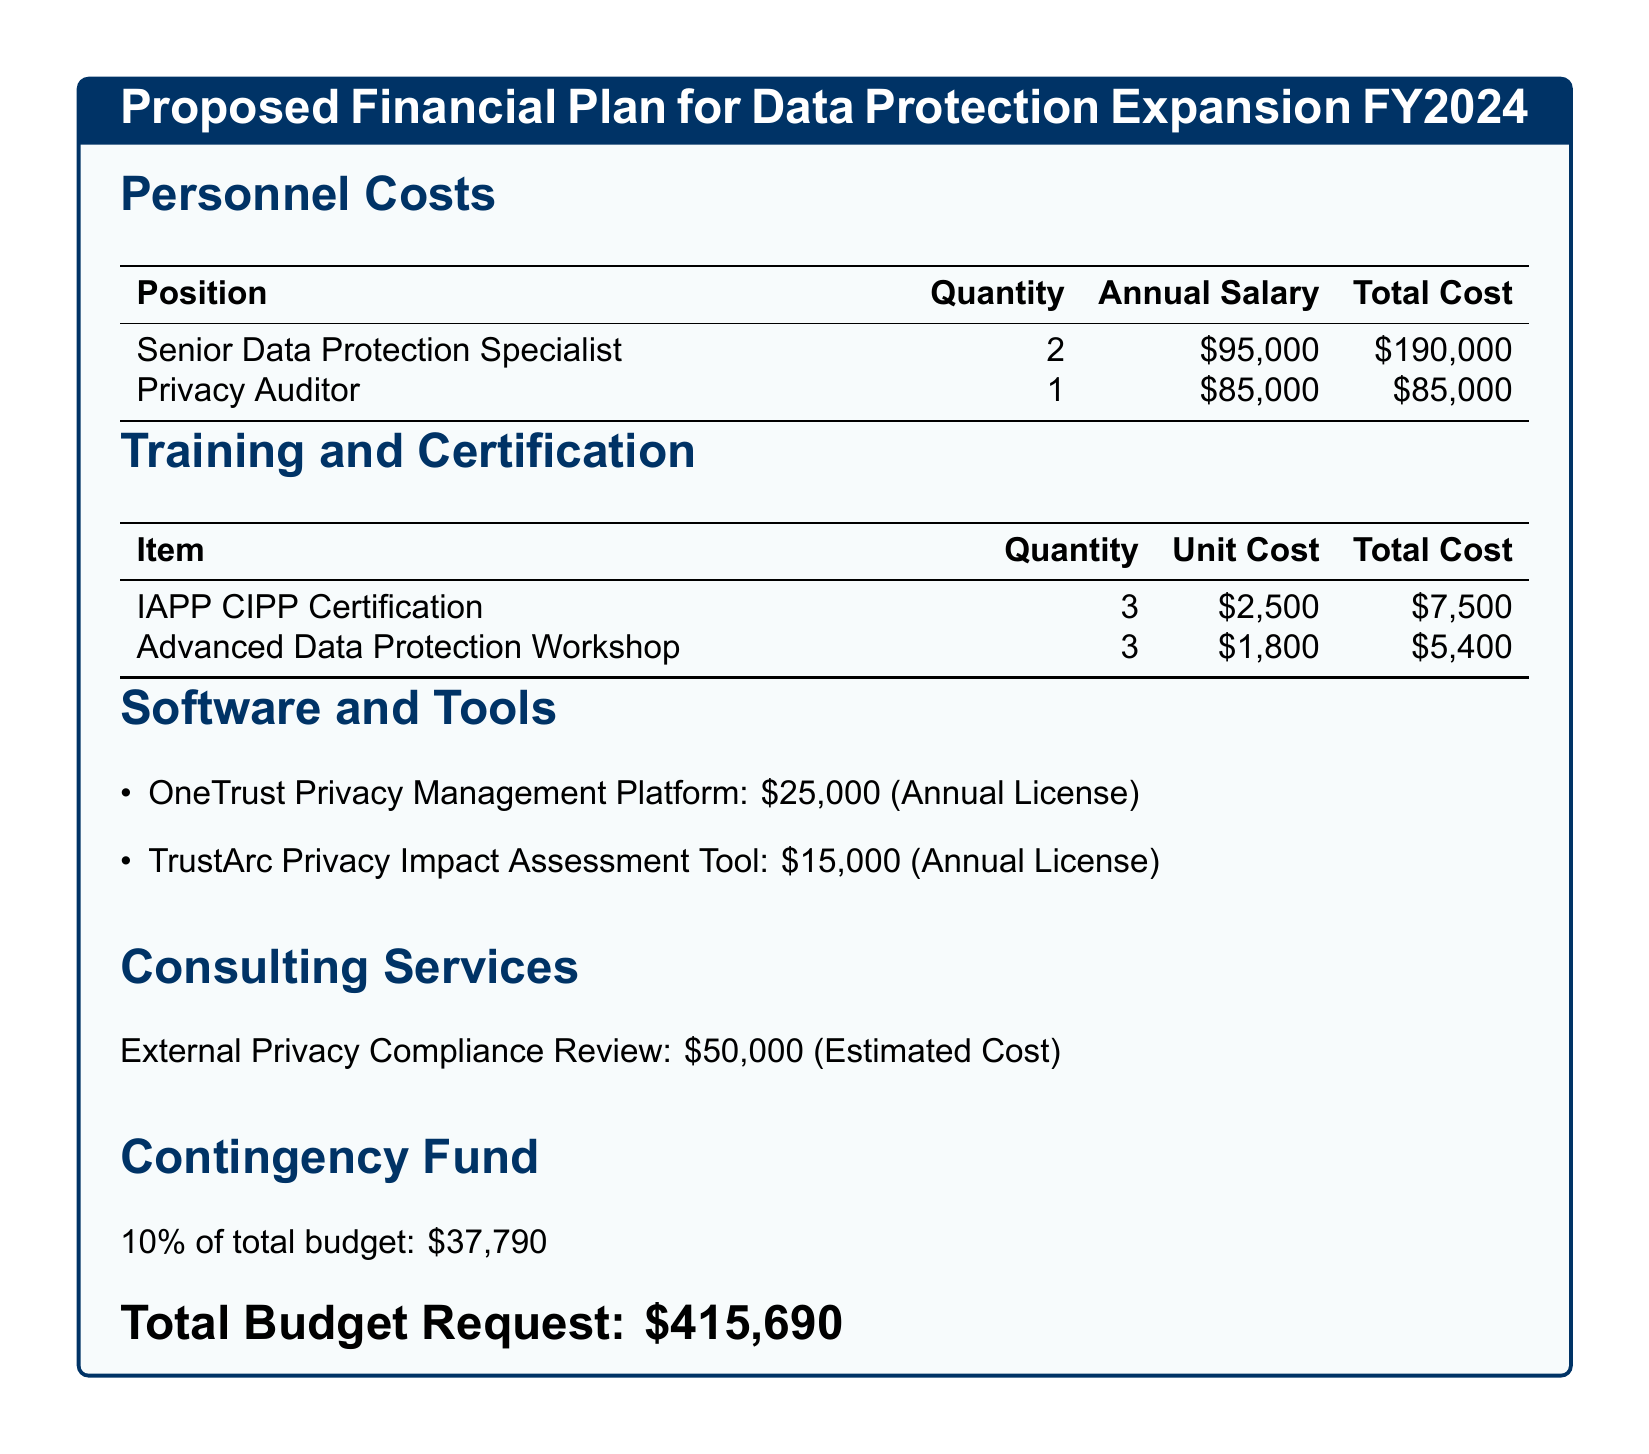What is the total budget request? The total budget request is clearly stated at the end of the document, which summarizes all costs involved.
Answer: $415,690 How many Senior Data Protection Specialists are proposed to be hired? The document lists the quantity of Senior Data Protection Specialists in the personnel costs section.
Answer: 2 What is the annual salary of a Privacy Auditor? The annual salary for a Privacy Auditor is specified in the table under personnel costs.
Answer: $85,000 What is the total cost for the IAPP CIPP Certification training? The total cost for IAPP CIPP Certification is calculated based on the quantity and unit cost provided in the training section.
Answer: $7,500 What percentage of the total budget is allocated for the contingency fund? The document explicitly mentions that the contingency fund is 10% of the total budget.
Answer: 10% What is the total cost for software and tools? The total cost for software and tools is found in the list of items under the software and tools section.
Answer: $40,000 How many Privacy Auditors are included in the hiring plan? The number of Privacy Auditors is provided in the personnel costs section.
Answer: 1 What is the estimated cost for consulting services? The document states the estimated cost for external privacy compliance review under consulting services.
Answer: $50,000 